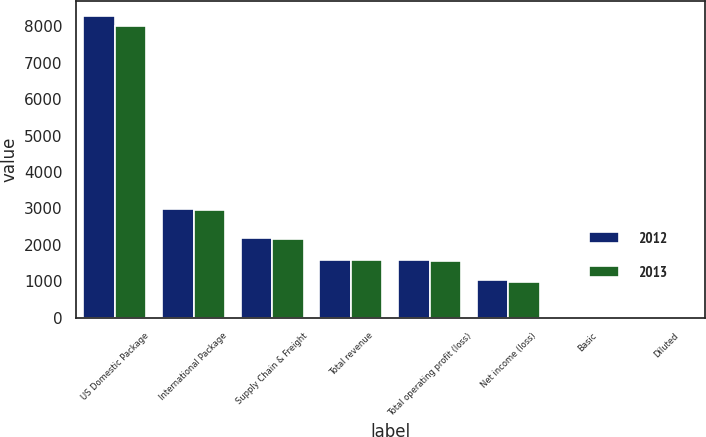Convert chart to OTSL. <chart><loc_0><loc_0><loc_500><loc_500><stacked_bar_chart><ecel><fcel>US Domestic Package<fcel>International Package<fcel>Supply Chain & Freight<fcel>Total revenue<fcel>Total operating profit (loss)<fcel>Net income (loss)<fcel>Basic<fcel>Diluted<nl><fcel>2012<fcel>8271<fcel>2978<fcel>2185<fcel>1574.5<fcel>1580<fcel>1037<fcel>1.09<fcel>1.08<nl><fcel>2013<fcel>8004<fcel>2966<fcel>2166<fcel>1574.5<fcel>1569<fcel>970<fcel>1.01<fcel>1<nl></chart> 